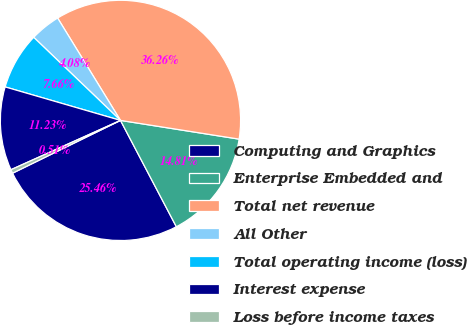<chart> <loc_0><loc_0><loc_500><loc_500><pie_chart><fcel>Computing and Graphics<fcel>Enterprise Embedded and<fcel>Total net revenue<fcel>All Other<fcel>Total operating income (loss)<fcel>Interest expense<fcel>Loss before income taxes<nl><fcel>25.46%<fcel>14.81%<fcel>36.26%<fcel>4.08%<fcel>7.66%<fcel>11.23%<fcel>0.51%<nl></chart> 